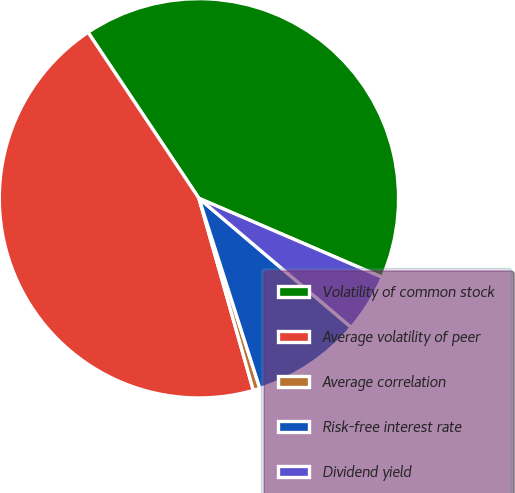Convert chart. <chart><loc_0><loc_0><loc_500><loc_500><pie_chart><fcel>Volatility of common stock<fcel>Average volatility of peer<fcel>Average correlation<fcel>Risk-free interest rate<fcel>Dividend yield<nl><fcel>40.85%<fcel>45.02%<fcel>0.54%<fcel>8.88%<fcel>4.71%<nl></chart> 